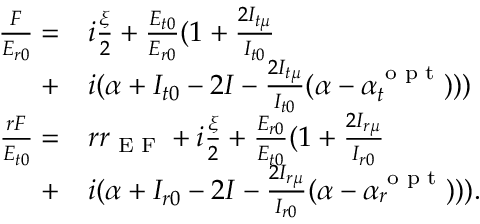Convert formula to latex. <formula><loc_0><loc_0><loc_500><loc_500>\begin{array} { r l } { \frac { F } { E _ { r 0 } } = } & { i \frac { \xi } { 2 } + \frac { E _ { t 0 } } { E _ { r 0 } } ( 1 + \frac { 2 I _ { t \mu } } { I _ { t 0 } } } \\ { + } & { i ( \alpha + I _ { t 0 } - 2 I - \frac { 2 I _ { t \mu } } { I _ { t 0 } } ( \alpha - \alpha _ { t } ^ { o p t } ) ) ) } \\ { \frac { r F } { E _ { t 0 } } = } & { r r _ { E F } + i \frac { \xi } { 2 } + \frac { E _ { r 0 } } { E _ { t 0 } } ( 1 + \frac { 2 I _ { r \mu } } { I _ { r 0 } } } \\ { + } & { i ( \alpha + I _ { r 0 } - 2 I - \frac { 2 I _ { r \mu } } { I _ { r 0 } } ( \alpha - \alpha _ { r } ^ { o p t } ) ) ) . } \end{array}</formula> 